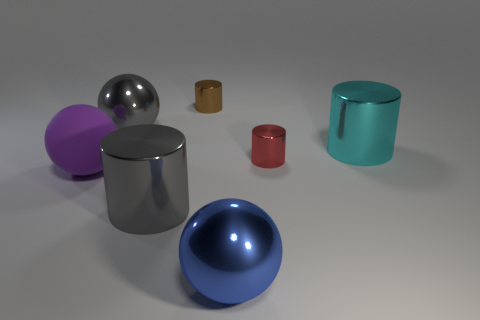Add 1 large cyan cubes. How many objects exist? 8 Subtract all cylinders. How many objects are left? 3 Subtract 0 gray cubes. How many objects are left? 7 Subtract all small green rubber cubes. Subtract all small red shiny things. How many objects are left? 6 Add 3 cyan cylinders. How many cyan cylinders are left? 4 Add 2 small green rubber objects. How many small green rubber objects exist? 2 